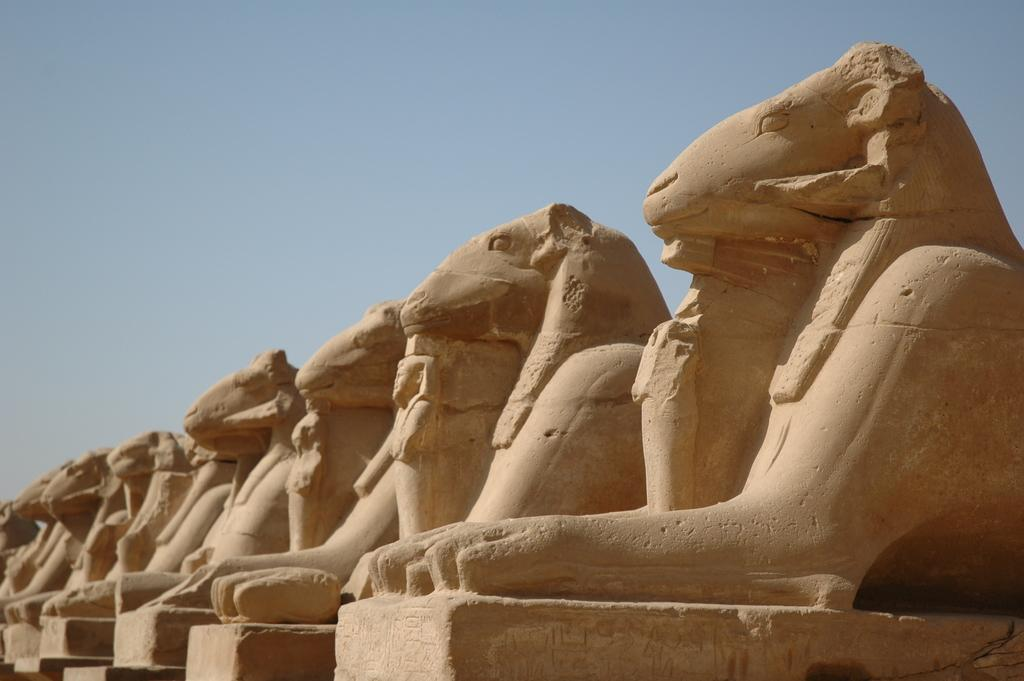What type of objects can be seen in the image? There are statues in the image. What advice can be seen written on the window in the image? There is no window or advice present in the image; it only features statues. 